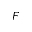Convert formula to latex. <formula><loc_0><loc_0><loc_500><loc_500>F</formula> 